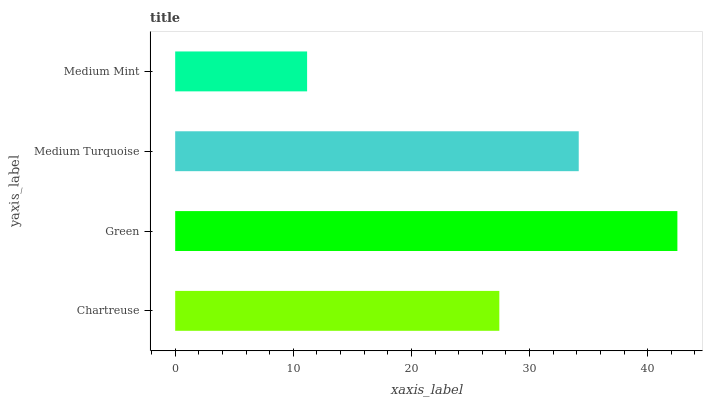Is Medium Mint the minimum?
Answer yes or no. Yes. Is Green the maximum?
Answer yes or no. Yes. Is Medium Turquoise the minimum?
Answer yes or no. No. Is Medium Turquoise the maximum?
Answer yes or no. No. Is Green greater than Medium Turquoise?
Answer yes or no. Yes. Is Medium Turquoise less than Green?
Answer yes or no. Yes. Is Medium Turquoise greater than Green?
Answer yes or no. No. Is Green less than Medium Turquoise?
Answer yes or no. No. Is Medium Turquoise the high median?
Answer yes or no. Yes. Is Chartreuse the low median?
Answer yes or no. Yes. Is Medium Mint the high median?
Answer yes or no. No. Is Green the low median?
Answer yes or no. No. 